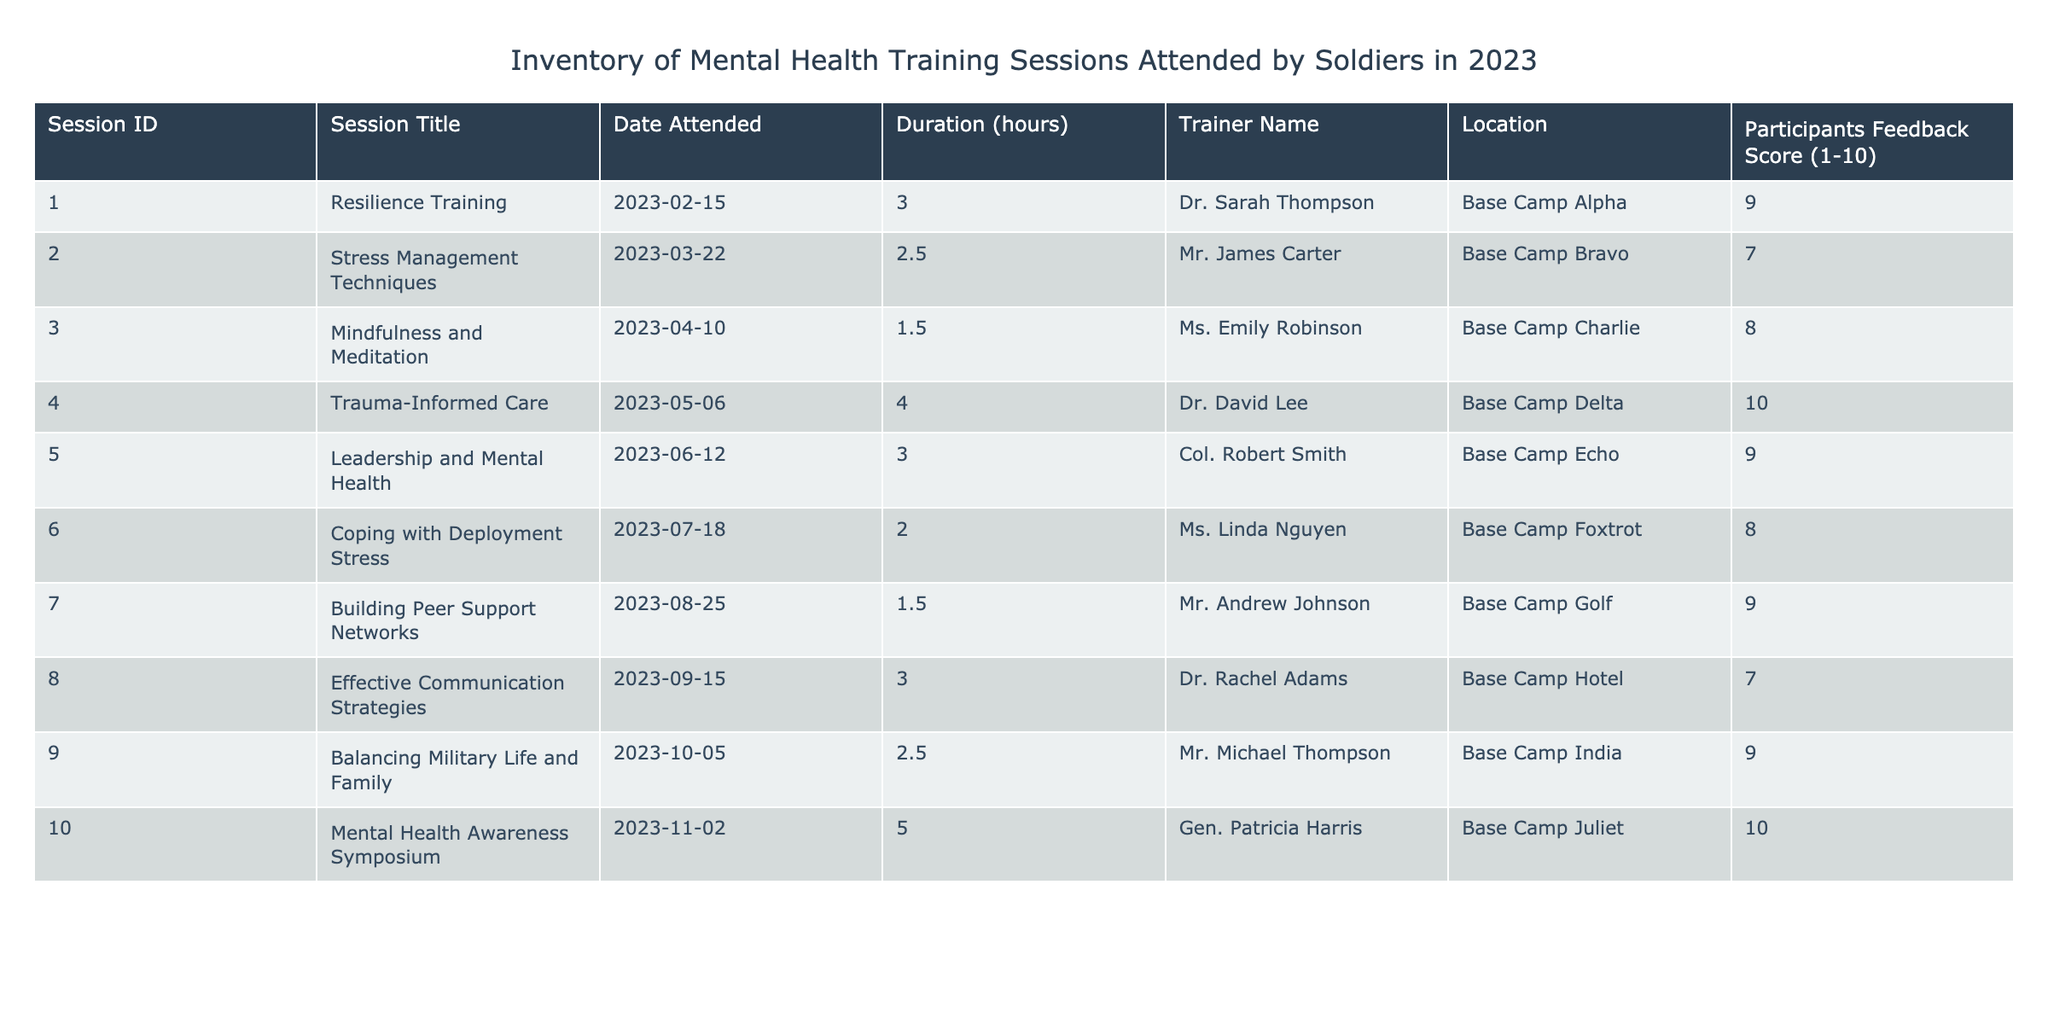What is the title of the training session with the highest feedback score? The highest feedback score in the table is 10, which corresponds to the 'Trauma-Informed Care' session.
Answer: Trauma-Informed Care How many training sessions were attended in total? The table presents 10 different training sessions, so the total is simply the count of rows.
Answer: 10 What was the average feedback score for all the training sessions? The sum of the feedback scores is (9 + 7 + 8 + 10 + 9 + 8 + 9 + 7 + 9 + 10) = 88. There are 10 sessions, so the average is 88/10 = 8.8.
Answer: 8.8 Did any training sessions receive a feedback score of 6 or lower? Reviewing the feedback scores, the lowest score is 7, meaning no session received a score of 6 or below.
Answer: No Which trainer conducted the session on 'Coping with Deployment Stress'? Referring to the table, the trainer for 'Coping with Deployment Stress' is Ms. Linda Nguyen.
Answer: Ms. Linda Nguyen What is the total duration of all training sessions combined? The total duration can be calculated by adding all individual durations together: (3 + 2.5 + 1.5 + 4 + 3 + 2 + 1.5 + 3 + 2.5 + 5) = 24.
Answer: 24 hours Which training session had the longest duration? The session with the longest duration is 'Mental Health Awareness Symposium,' lasting 5 hours.
Answer: Mental Health Awareness Symposium How many sessions took place in Base Camp Alpha? There is only one session listed under Base Camp Alpha, which is 'Resilience Training.'
Answer: 1 Which month had the most training sessions held? Analyzing the dates, there was one session each in February, March, April, May, June, July, August, September, October, and November, leading to a tie; every month listed has one session.
Answer: All listed months have one session 